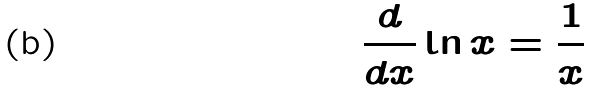Convert formula to latex. <formula><loc_0><loc_0><loc_500><loc_500>\frac { d } { d x } \ln x = \frac { 1 } { x }</formula> 